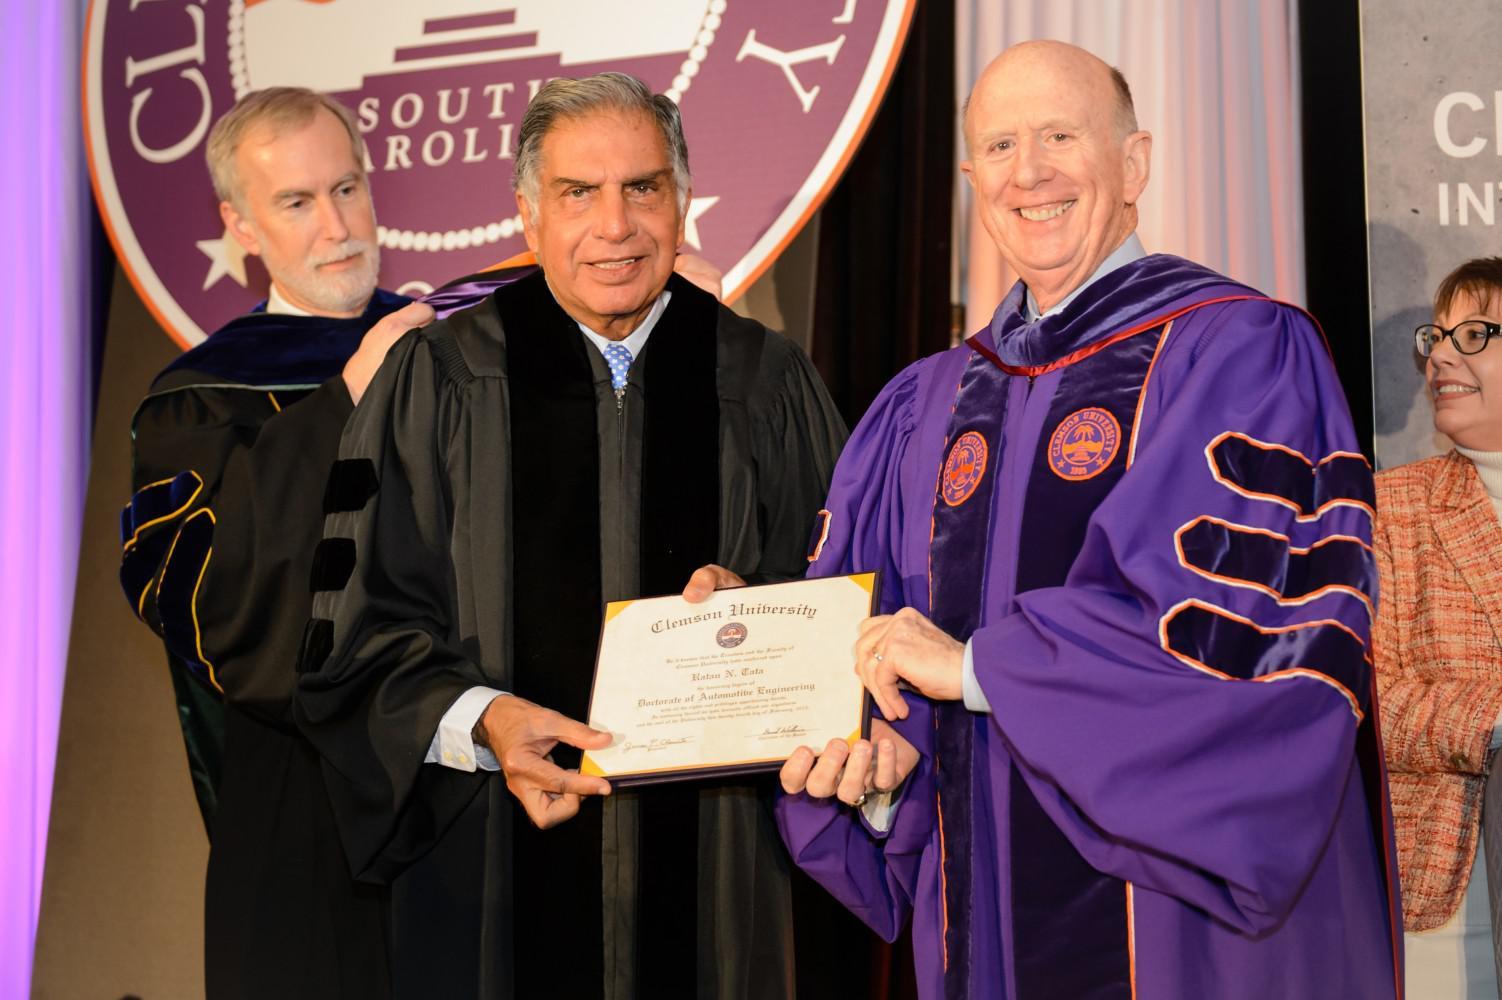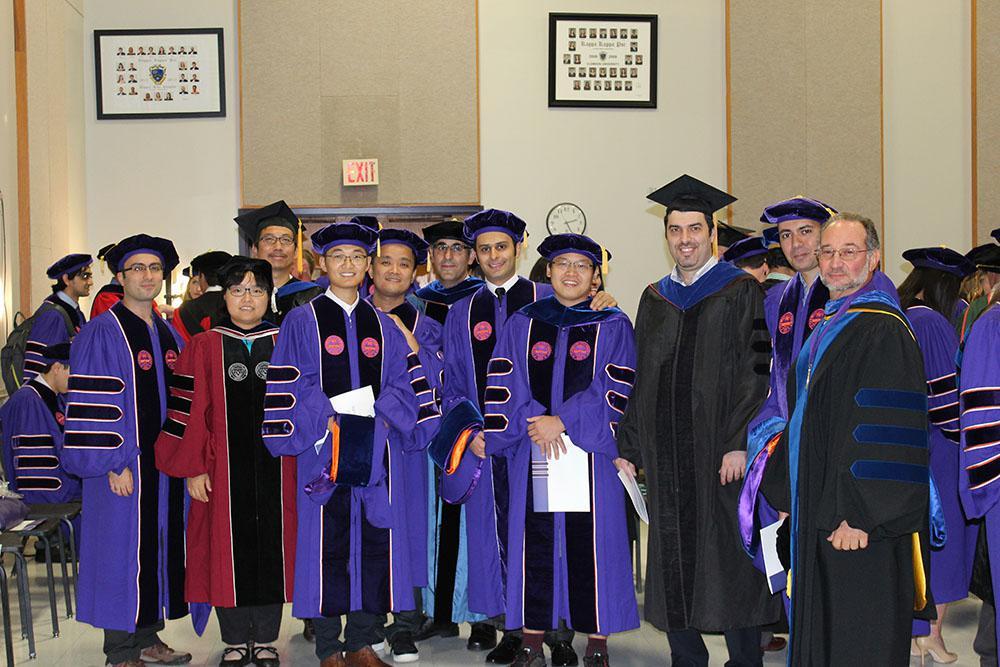The first image is the image on the left, the second image is the image on the right. Evaluate the accuracy of this statement regarding the images: "Two people pose together outside wearing graduation attire in one of the images.". Is it true? Answer yes or no. No. The first image is the image on the left, the second image is the image on the right. Given the left and right images, does the statement "The left image shows a round-faced man with mustache and beard wearing a graduation robe and gold-tasseled cap, and the right image shows people in different colored robes with stripes on the sleeves." hold true? Answer yes or no. No. 